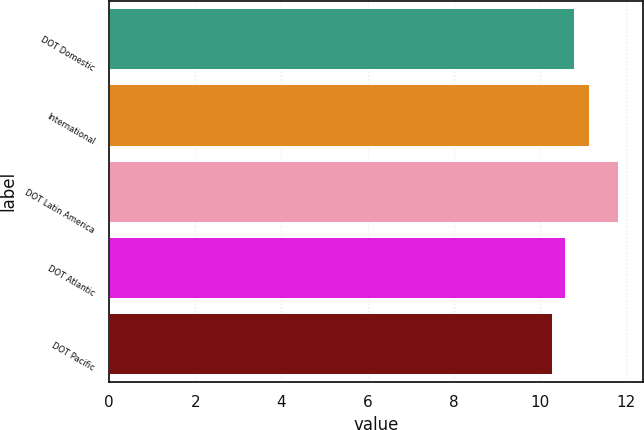Convert chart. <chart><loc_0><loc_0><loc_500><loc_500><bar_chart><fcel>DOT Domestic<fcel>International<fcel>DOT Latin America<fcel>DOT Atlantic<fcel>DOT Pacific<nl><fcel>10.8<fcel>11.14<fcel>11.8<fcel>10.58<fcel>10.29<nl></chart> 